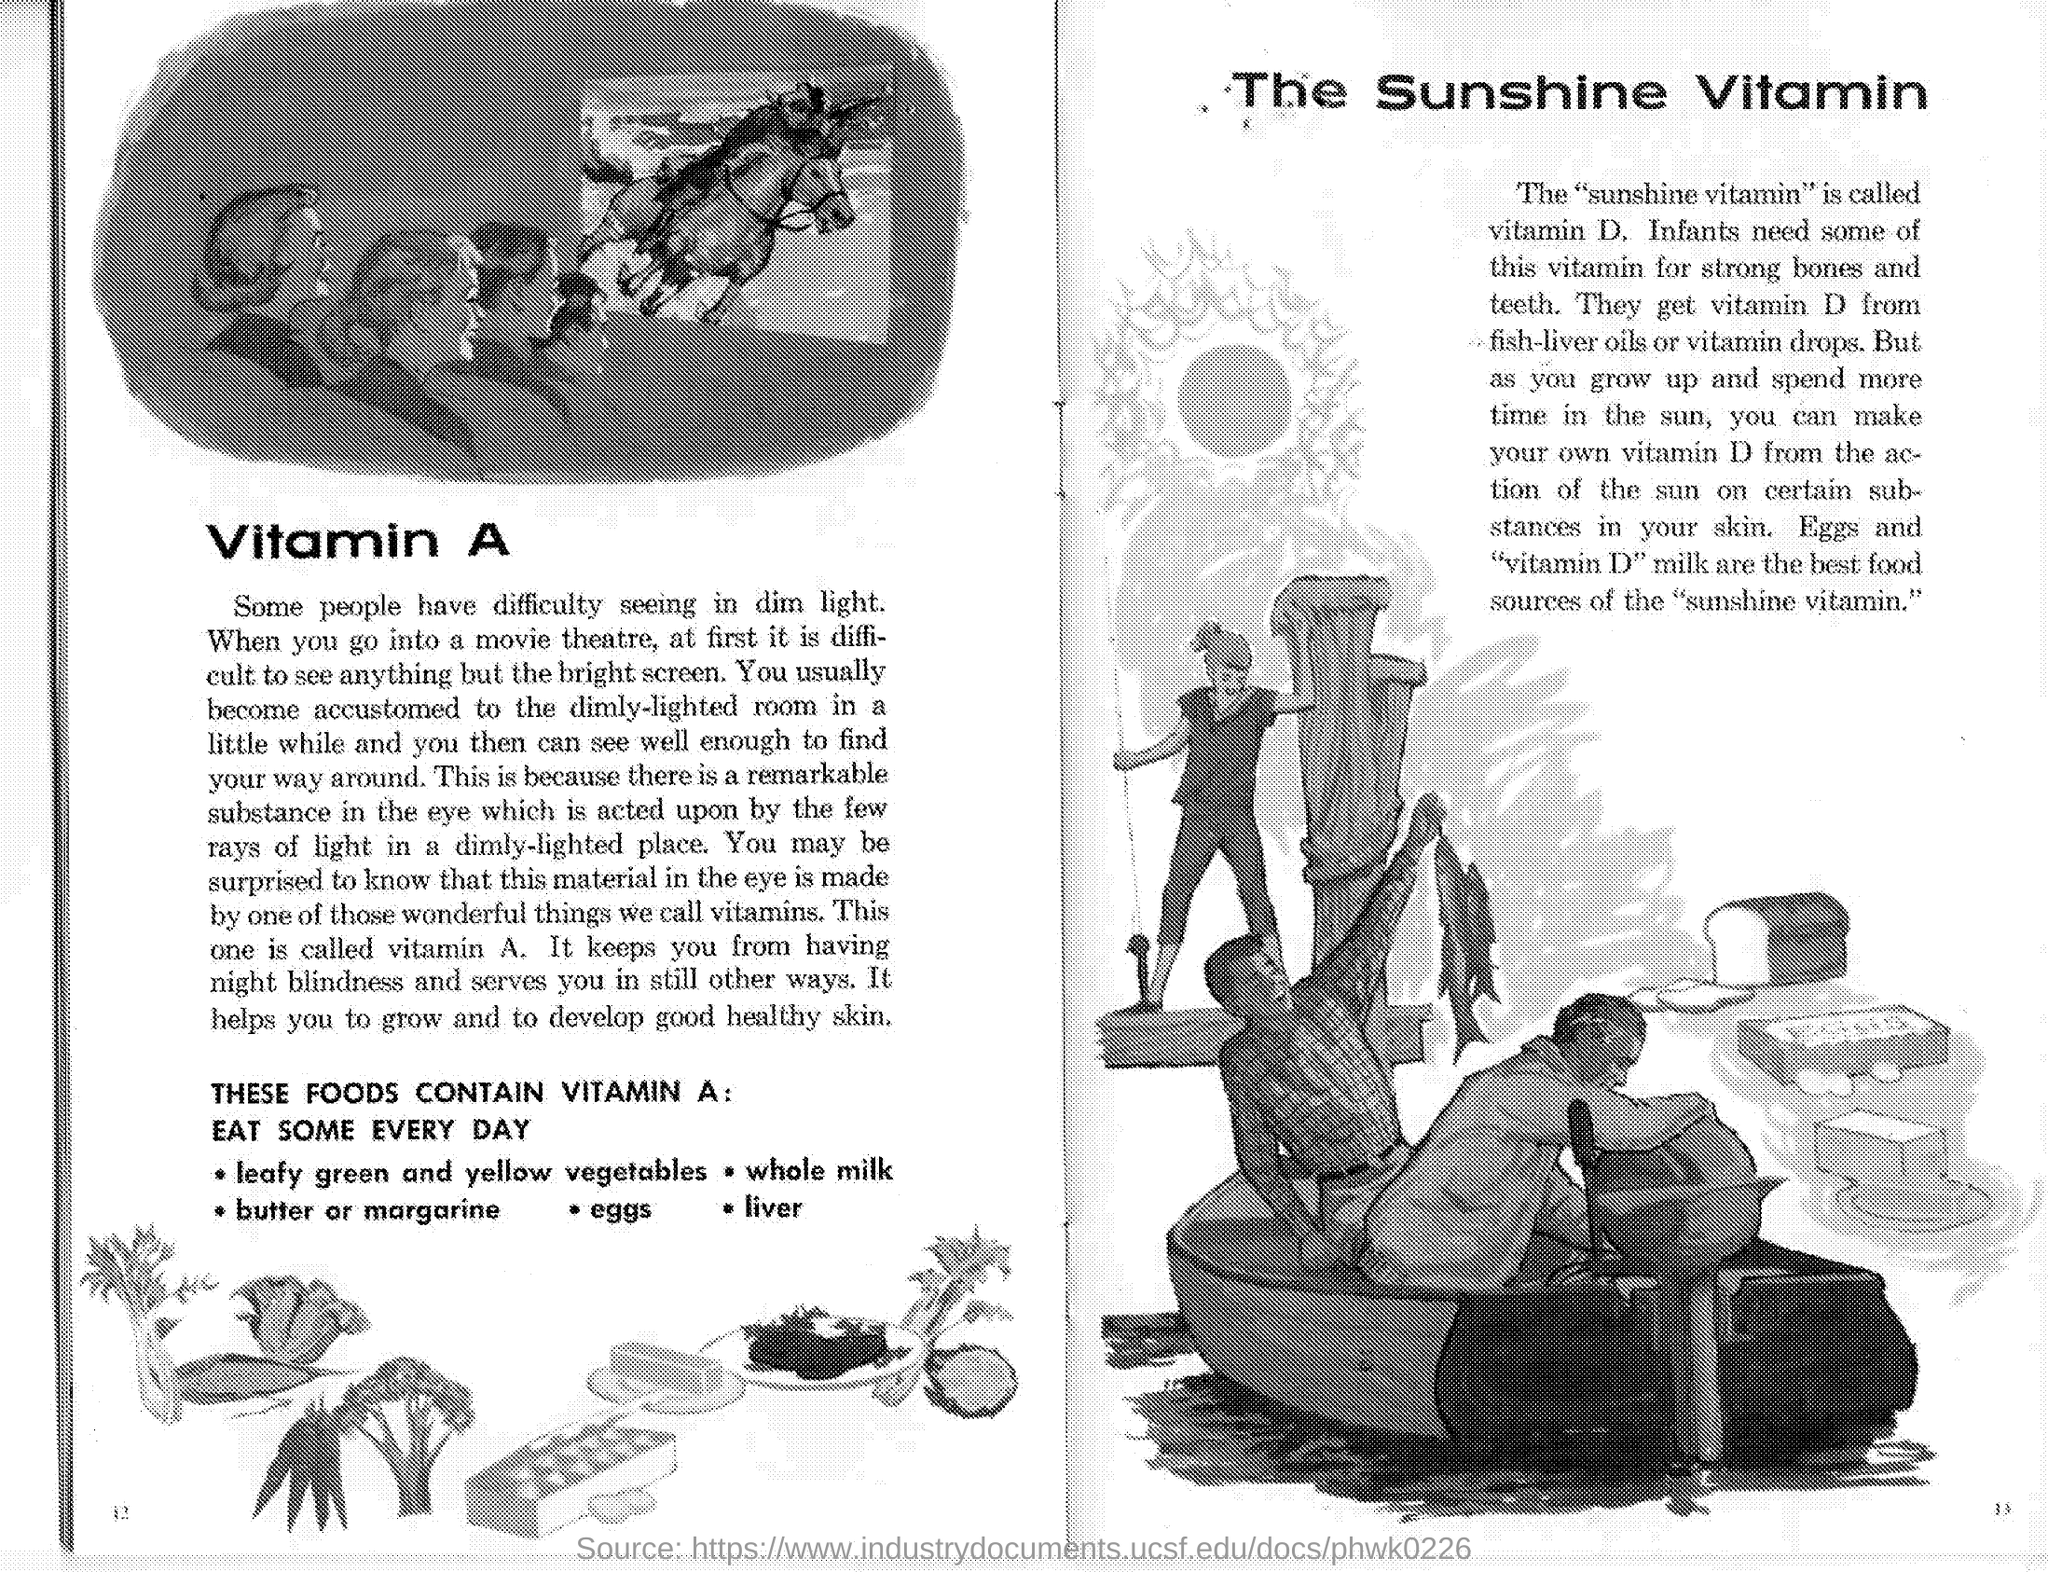Identify some key points in this picture. The sunshine vitamin is vitamin D. 